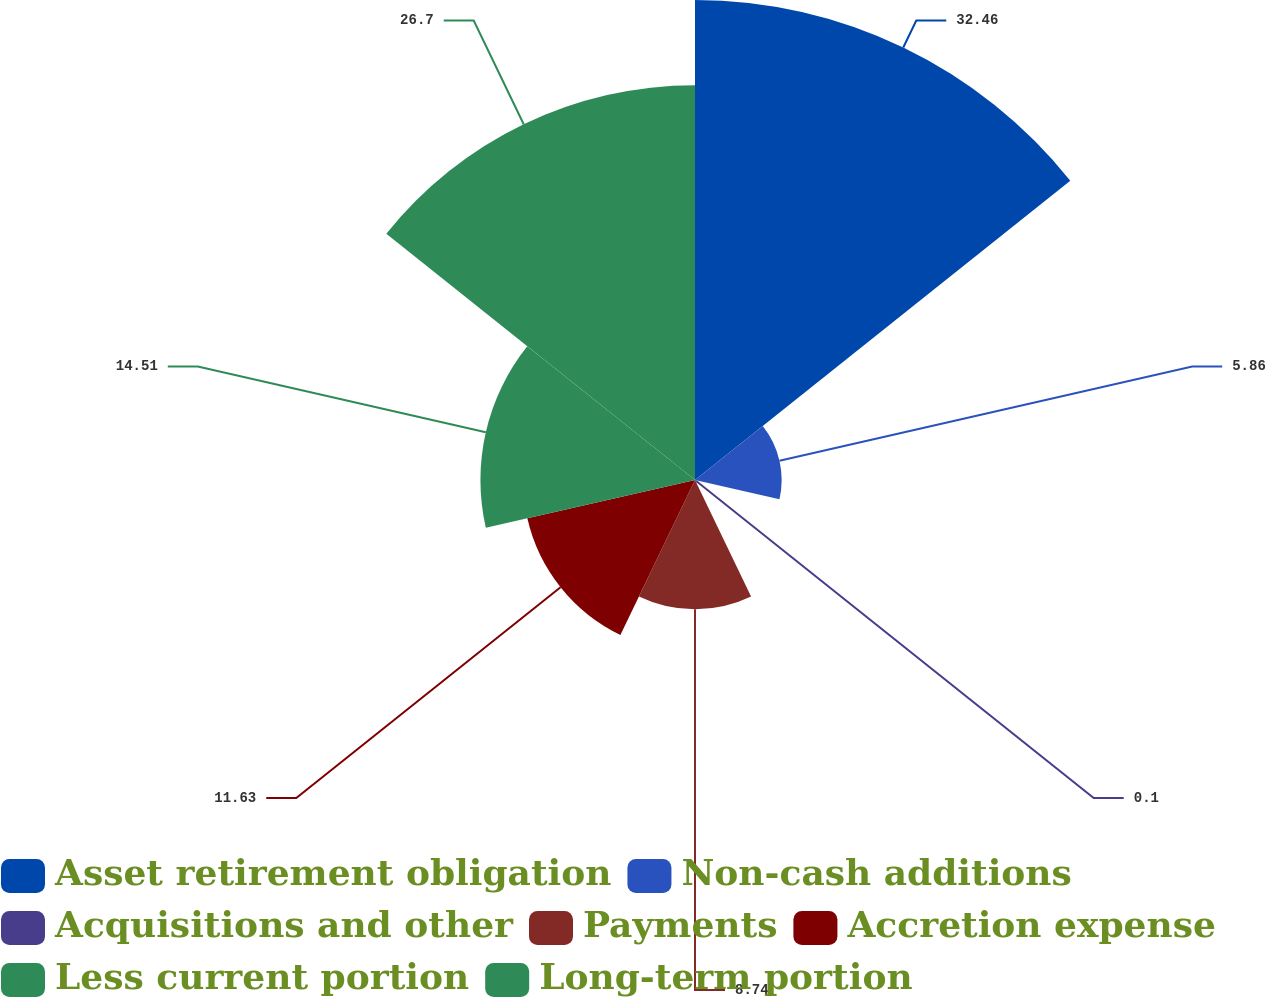<chart> <loc_0><loc_0><loc_500><loc_500><pie_chart><fcel>Asset retirement obligation<fcel>Non-cash additions<fcel>Acquisitions and other<fcel>Payments<fcel>Accretion expense<fcel>Less current portion<fcel>Long-term portion<nl><fcel>32.46%<fcel>5.86%<fcel>0.1%<fcel>8.74%<fcel>11.63%<fcel>14.51%<fcel>26.7%<nl></chart> 